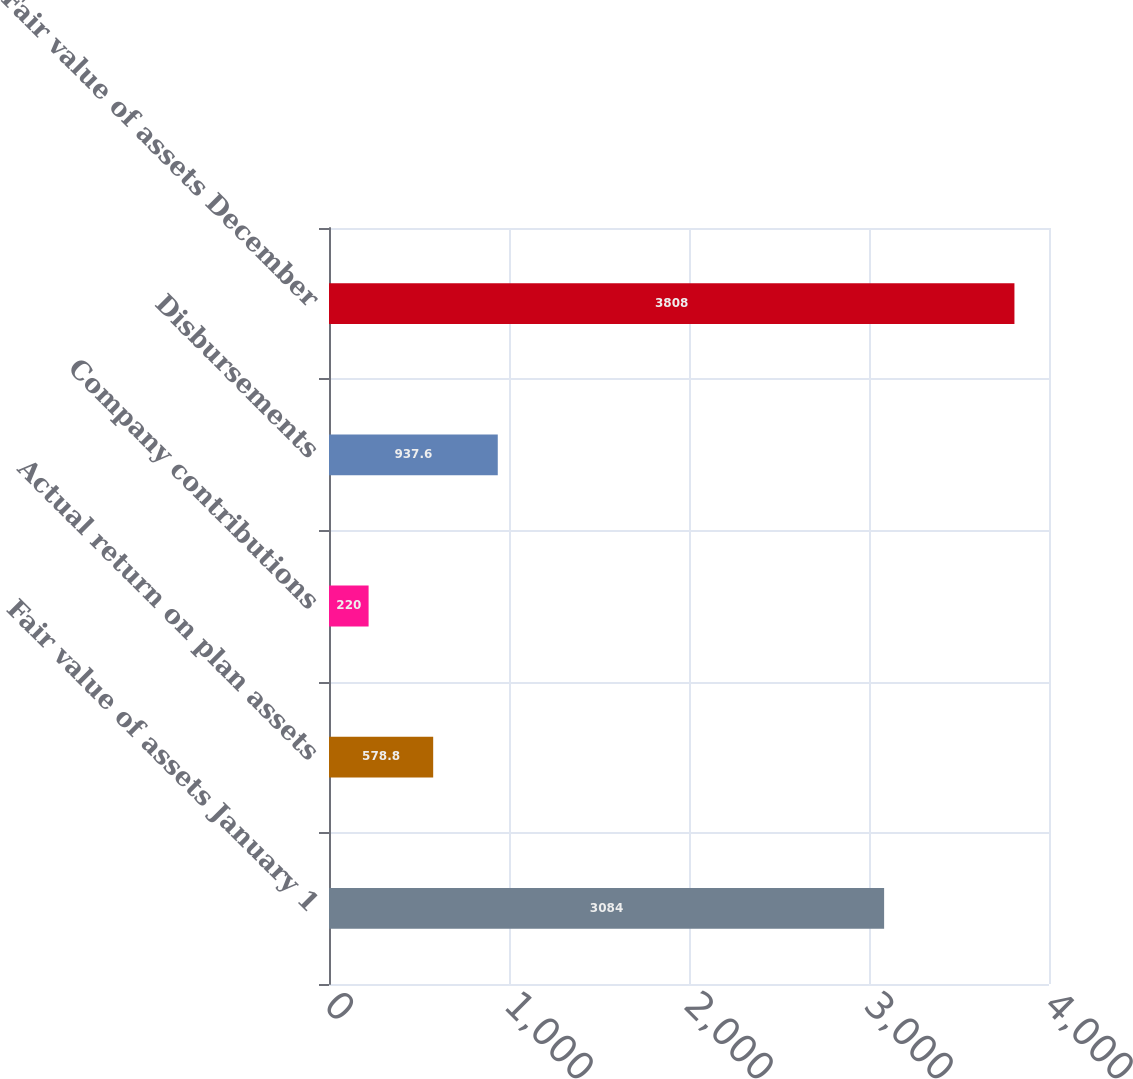<chart> <loc_0><loc_0><loc_500><loc_500><bar_chart><fcel>Fair value of assets January 1<fcel>Actual return on plan assets<fcel>Company contributions<fcel>Disbursements<fcel>Fair value of assets December<nl><fcel>3084<fcel>578.8<fcel>220<fcel>937.6<fcel>3808<nl></chart> 